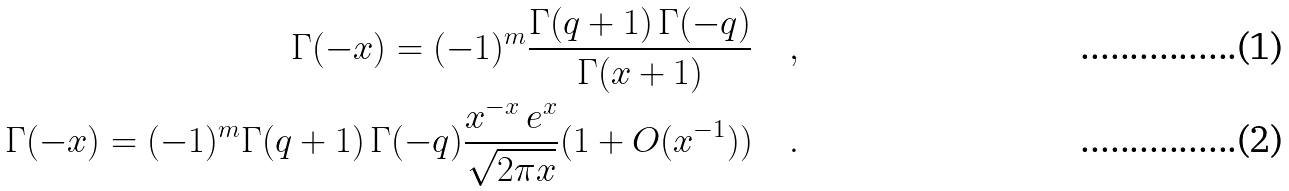<formula> <loc_0><loc_0><loc_500><loc_500>\Gamma ( - x ) = ( - 1 ) ^ { m } \frac { \Gamma ( q + 1 ) \, \Gamma ( - q ) } { \Gamma ( x + 1 ) } \quad , \\ \Gamma ( - x ) = ( - 1 ) ^ { m } \Gamma ( q + 1 ) \, \Gamma ( - q ) \frac { x ^ { - x } \, e ^ { x } } { \sqrt { 2 \pi x } } ( 1 + O ( x ^ { - 1 } ) ) \quad .</formula> 